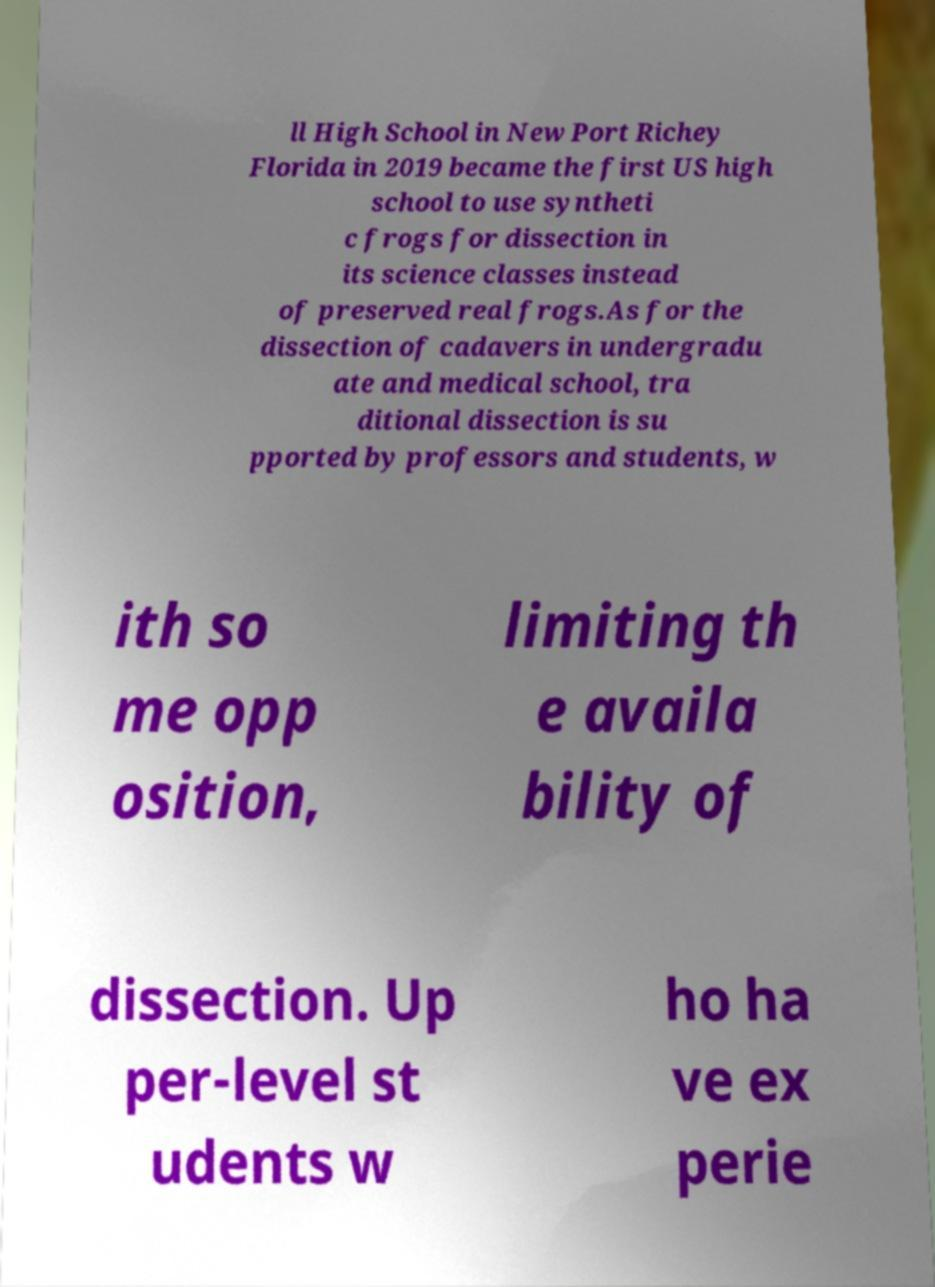Please read and relay the text visible in this image. What does it say? ll High School in New Port Richey Florida in 2019 became the first US high school to use syntheti c frogs for dissection in its science classes instead of preserved real frogs.As for the dissection of cadavers in undergradu ate and medical school, tra ditional dissection is su pported by professors and students, w ith so me opp osition, limiting th e availa bility of dissection. Up per-level st udents w ho ha ve ex perie 